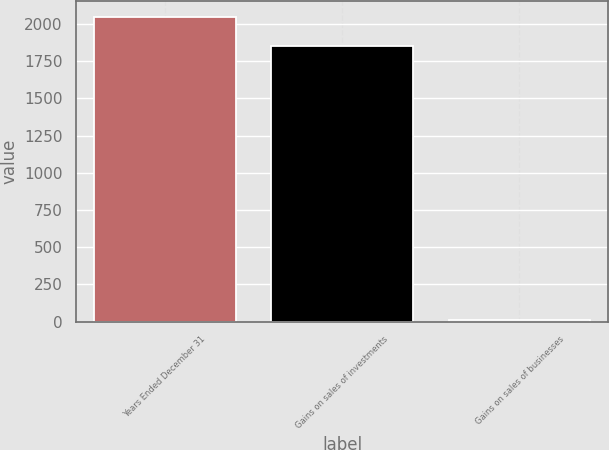Convert chart to OTSL. <chart><loc_0><loc_0><loc_500><loc_500><bar_chart><fcel>Years Ended December 31<fcel>Gains on sales of investments<fcel>Gains on sales of businesses<nl><fcel>2047.2<fcel>1848<fcel>13<nl></chart> 